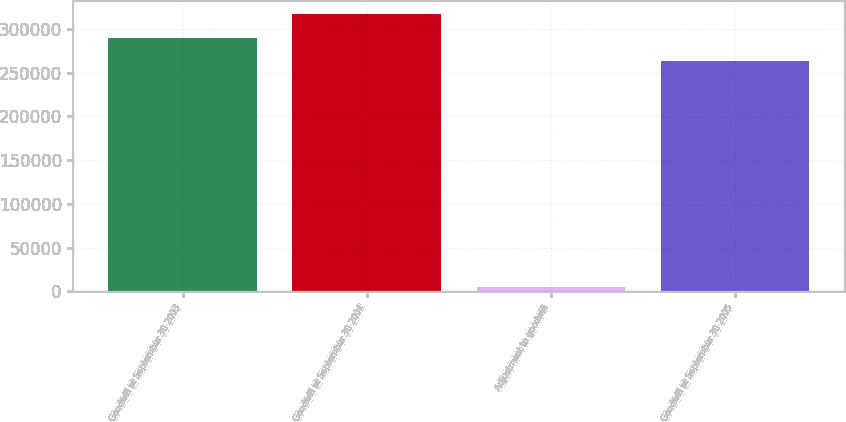Convert chart to OTSL. <chart><loc_0><loc_0><loc_500><loc_500><bar_chart><fcel>Goodwill at September 30 2003<fcel>Goodwill at September 30 2004<fcel>Adjustment to goodwill<fcel>Goodwill at September 30 2005<nl><fcel>290011<fcel>316375<fcel>5310<fcel>263646<nl></chart> 